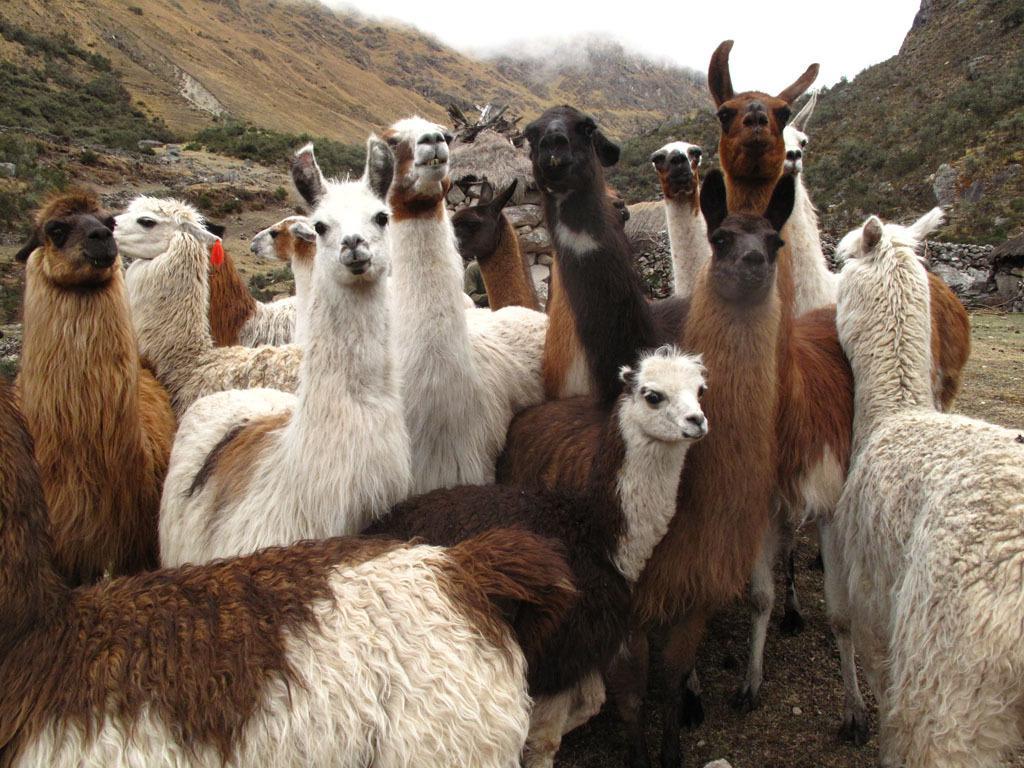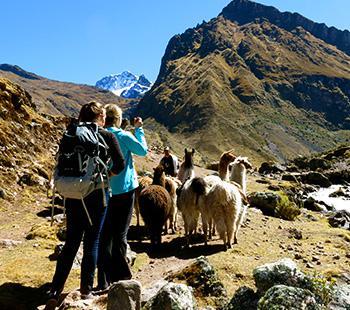The first image is the image on the left, the second image is the image on the right. Evaluate the accuracy of this statement regarding the images: "In one image, a single llama without a pack is standing on a cliff edge overlooking scenery with mountains in the background.". Is it true? Answer yes or no. No. The first image is the image on the left, the second image is the image on the right. Considering the images on both sides, is "At least three animals are on the mountain together in each picture." valid? Answer yes or no. Yes. 